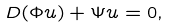<formula> <loc_0><loc_0><loc_500><loc_500>D ( \Phi u ) + \Psi u = 0 ,</formula> 